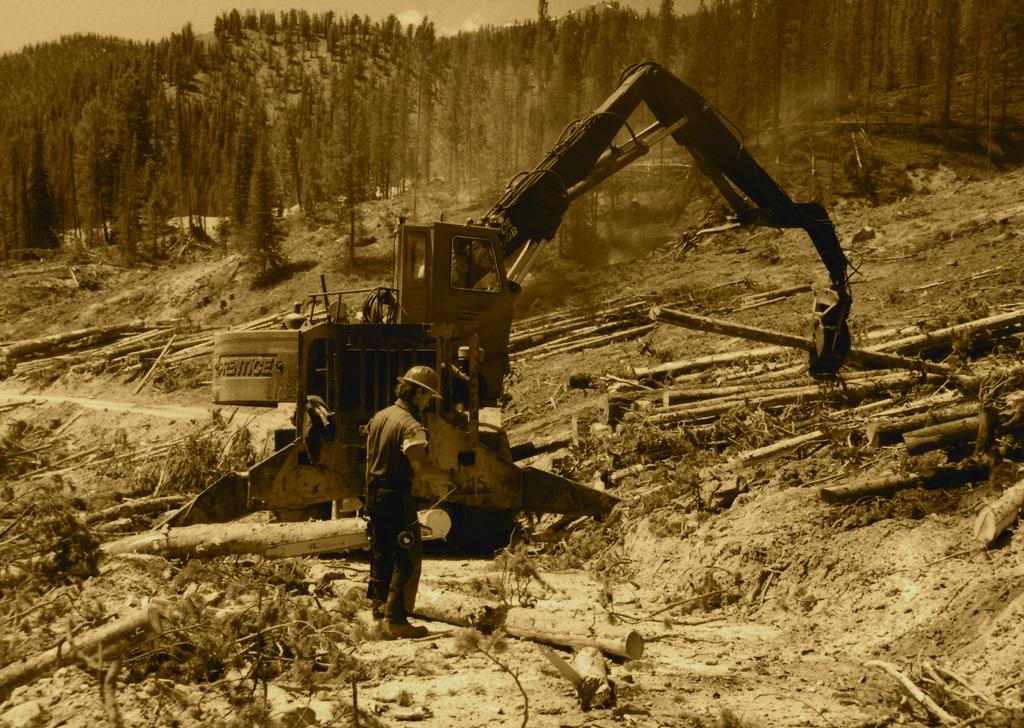What is the main subject of the image? There is a person standing in the image. What type of machinery can be seen in the image? There is a hydraulic excavator in the image. What is visible beneath the person and machinery? The ground is visible in the image. What type of objects are made of wood in the image? There are wooden objects in the image. What can be seen in the distance behind the person and machinery? There are trees and the sky visible in the background of the image. How many eggs are being used to control the hydraulic excavator in the image? There are no eggs present in the image, and eggs are not used to control hydraulic excavators. 